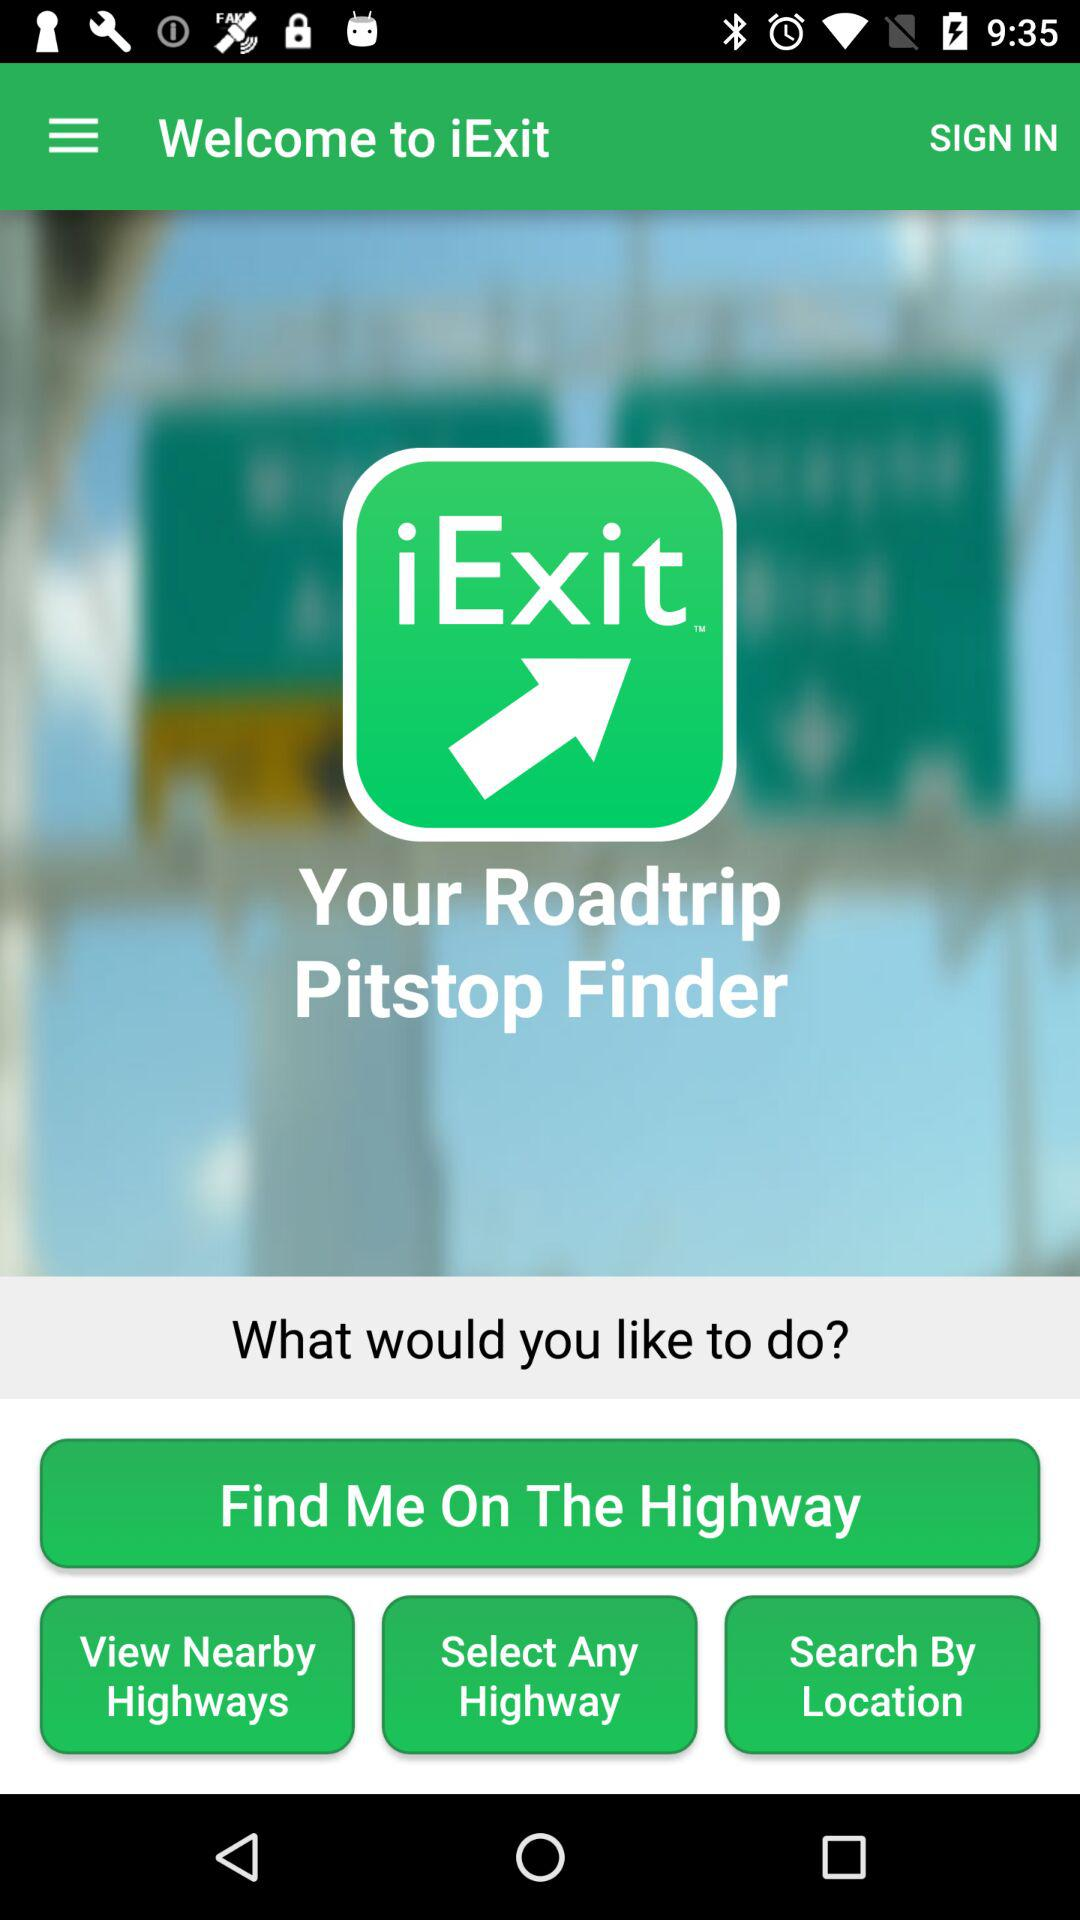What exactly does this app do?
When the provided information is insufficient, respond with <no answer>. <no answer> 